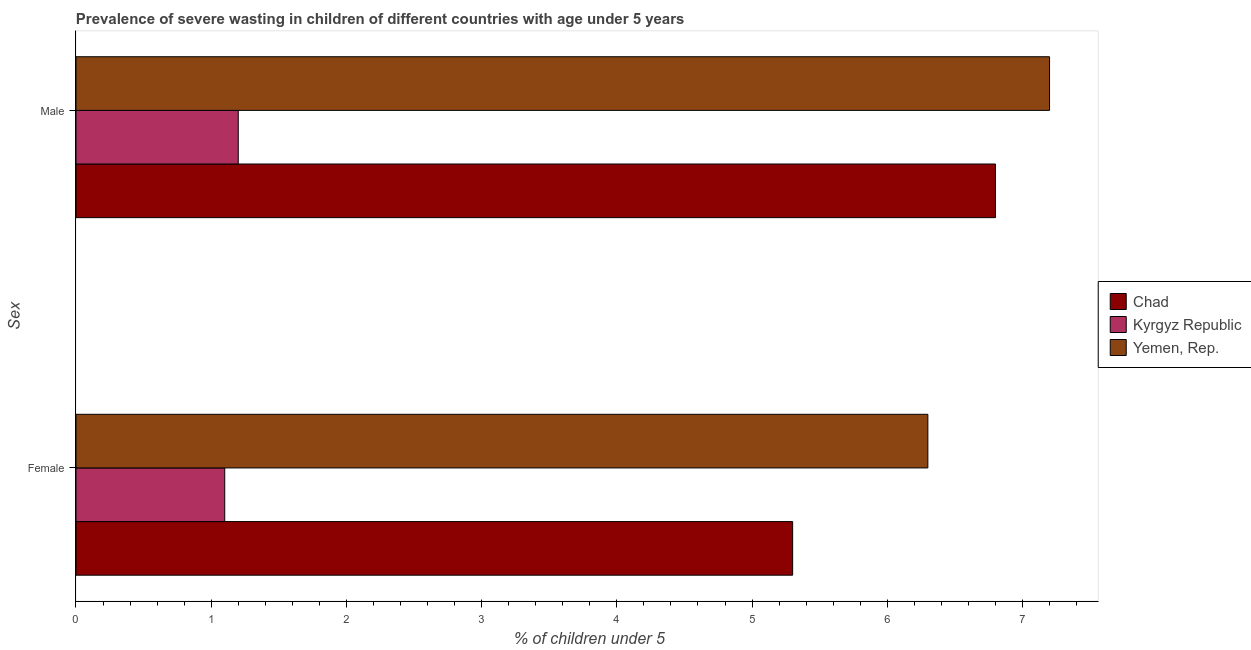How many different coloured bars are there?
Your answer should be very brief. 3. How many groups of bars are there?
Offer a very short reply. 2. Are the number of bars on each tick of the Y-axis equal?
Make the answer very short. Yes. What is the percentage of undernourished male children in Kyrgyz Republic?
Give a very brief answer. 1.2. Across all countries, what is the maximum percentage of undernourished male children?
Provide a succinct answer. 7.2. Across all countries, what is the minimum percentage of undernourished male children?
Your response must be concise. 1.2. In which country was the percentage of undernourished male children maximum?
Your response must be concise. Yemen, Rep. In which country was the percentage of undernourished male children minimum?
Your answer should be very brief. Kyrgyz Republic. What is the total percentage of undernourished male children in the graph?
Your answer should be very brief. 15.2. What is the difference between the percentage of undernourished female children in Kyrgyz Republic and that in Chad?
Offer a very short reply. -4.2. What is the difference between the percentage of undernourished male children in Yemen, Rep. and the percentage of undernourished female children in Kyrgyz Republic?
Offer a terse response. 6.1. What is the average percentage of undernourished female children per country?
Offer a very short reply. 4.23. What is the difference between the percentage of undernourished male children and percentage of undernourished female children in Kyrgyz Republic?
Provide a short and direct response. 0.1. In how many countries, is the percentage of undernourished female children greater than 5 %?
Your response must be concise. 2. What is the ratio of the percentage of undernourished female children in Chad to that in Yemen, Rep.?
Give a very brief answer. 0.84. What does the 3rd bar from the top in Female represents?
Give a very brief answer. Chad. What does the 1st bar from the bottom in Male represents?
Ensure brevity in your answer.  Chad. Are all the bars in the graph horizontal?
Your response must be concise. Yes. How many countries are there in the graph?
Your answer should be compact. 3. Are the values on the major ticks of X-axis written in scientific E-notation?
Your response must be concise. No. Does the graph contain grids?
Offer a terse response. No. What is the title of the graph?
Your response must be concise. Prevalence of severe wasting in children of different countries with age under 5 years. Does "Other small states" appear as one of the legend labels in the graph?
Make the answer very short. No. What is the label or title of the X-axis?
Keep it short and to the point.  % of children under 5. What is the label or title of the Y-axis?
Provide a short and direct response. Sex. What is the  % of children under 5 in Chad in Female?
Give a very brief answer. 5.3. What is the  % of children under 5 of Kyrgyz Republic in Female?
Your response must be concise. 1.1. What is the  % of children under 5 in Yemen, Rep. in Female?
Ensure brevity in your answer.  6.3. What is the  % of children under 5 of Chad in Male?
Offer a terse response. 6.8. What is the  % of children under 5 in Kyrgyz Republic in Male?
Provide a succinct answer. 1.2. What is the  % of children under 5 of Yemen, Rep. in Male?
Provide a succinct answer. 7.2. Across all Sex, what is the maximum  % of children under 5 of Chad?
Your response must be concise. 6.8. Across all Sex, what is the maximum  % of children under 5 in Kyrgyz Republic?
Your response must be concise. 1.2. Across all Sex, what is the maximum  % of children under 5 of Yemen, Rep.?
Offer a terse response. 7.2. Across all Sex, what is the minimum  % of children under 5 in Chad?
Your response must be concise. 5.3. Across all Sex, what is the minimum  % of children under 5 of Kyrgyz Republic?
Ensure brevity in your answer.  1.1. Across all Sex, what is the minimum  % of children under 5 of Yemen, Rep.?
Offer a terse response. 6.3. What is the difference between the  % of children under 5 of Kyrgyz Republic in Female and that in Male?
Give a very brief answer. -0.1. What is the difference between the  % of children under 5 in Kyrgyz Republic in Female and the  % of children under 5 in Yemen, Rep. in Male?
Your answer should be very brief. -6.1. What is the average  % of children under 5 of Chad per Sex?
Your response must be concise. 6.05. What is the average  % of children under 5 of Kyrgyz Republic per Sex?
Keep it short and to the point. 1.15. What is the average  % of children under 5 of Yemen, Rep. per Sex?
Ensure brevity in your answer.  6.75. What is the difference between the  % of children under 5 of Chad and  % of children under 5 of Kyrgyz Republic in Male?
Provide a short and direct response. 5.6. What is the difference between the  % of children under 5 in Chad and  % of children under 5 in Yemen, Rep. in Male?
Offer a very short reply. -0.4. What is the difference between the  % of children under 5 in Kyrgyz Republic and  % of children under 5 in Yemen, Rep. in Male?
Give a very brief answer. -6. What is the ratio of the  % of children under 5 of Chad in Female to that in Male?
Offer a terse response. 0.78. What is the ratio of the  % of children under 5 in Kyrgyz Republic in Female to that in Male?
Give a very brief answer. 0.92. What is the ratio of the  % of children under 5 in Yemen, Rep. in Female to that in Male?
Keep it short and to the point. 0.88. What is the difference between the highest and the second highest  % of children under 5 in Chad?
Offer a terse response. 1.5. What is the difference between the highest and the second highest  % of children under 5 in Kyrgyz Republic?
Provide a short and direct response. 0.1. What is the difference between the highest and the second highest  % of children under 5 of Yemen, Rep.?
Keep it short and to the point. 0.9. What is the difference between the highest and the lowest  % of children under 5 in Chad?
Offer a very short reply. 1.5. What is the difference between the highest and the lowest  % of children under 5 of Yemen, Rep.?
Give a very brief answer. 0.9. 